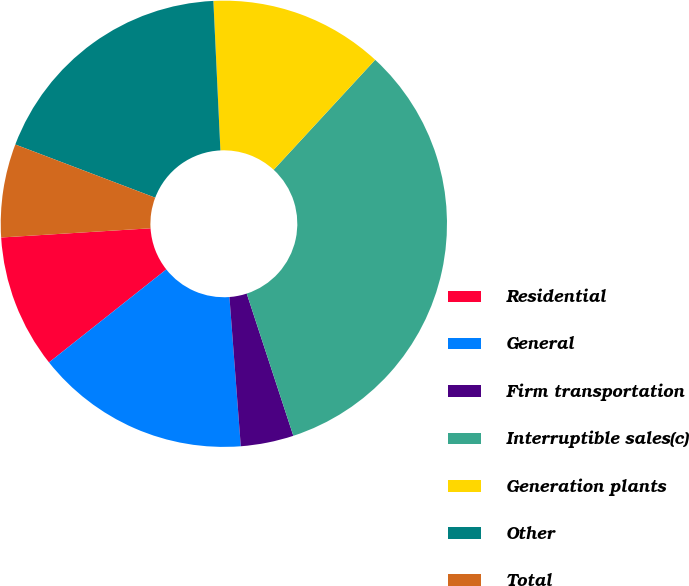Convert chart. <chart><loc_0><loc_0><loc_500><loc_500><pie_chart><fcel>Residential<fcel>General<fcel>Firm transportation<fcel>Interruptible sales(c)<fcel>Generation plants<fcel>Other<fcel>Total<nl><fcel>9.69%<fcel>15.54%<fcel>3.83%<fcel>33.1%<fcel>12.61%<fcel>18.47%<fcel>6.76%<nl></chart> 